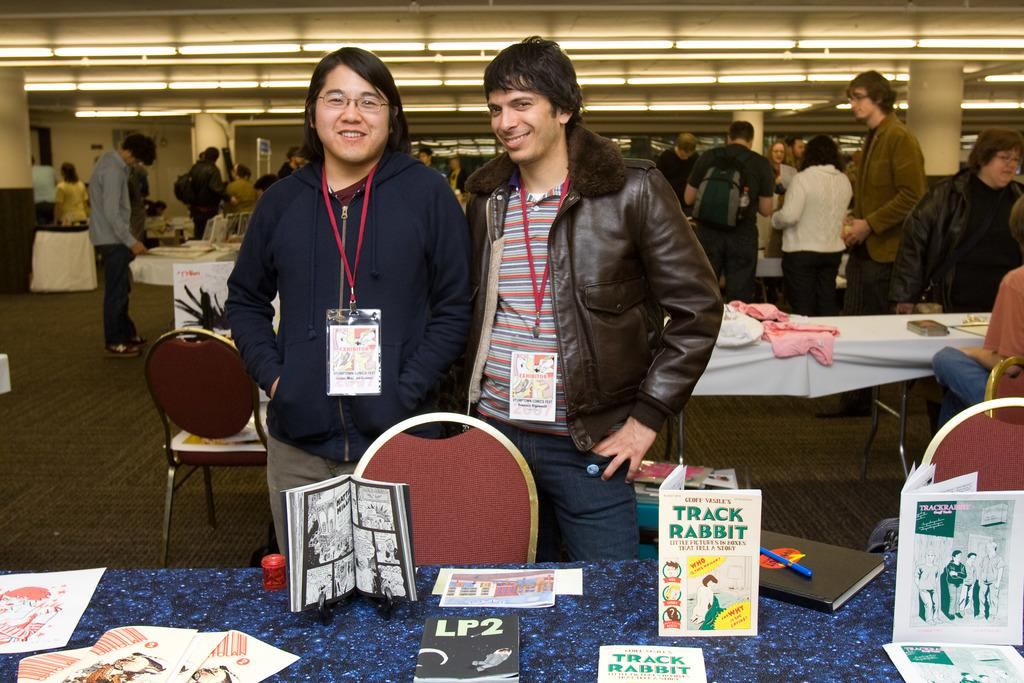<image>
Offer a succinct explanation of the picture presented. A group of people are browsing a row of tables with a book that says LP2. 